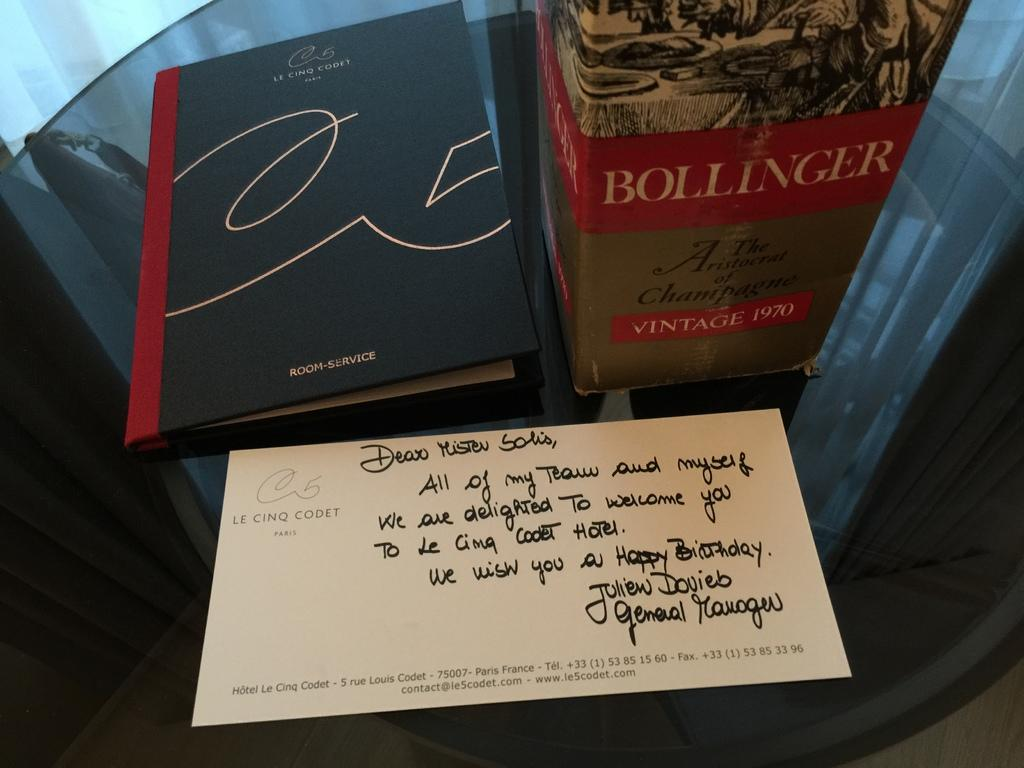<image>
Provide a brief description of the given image. A beverage that has a happy birthday message next to it. 